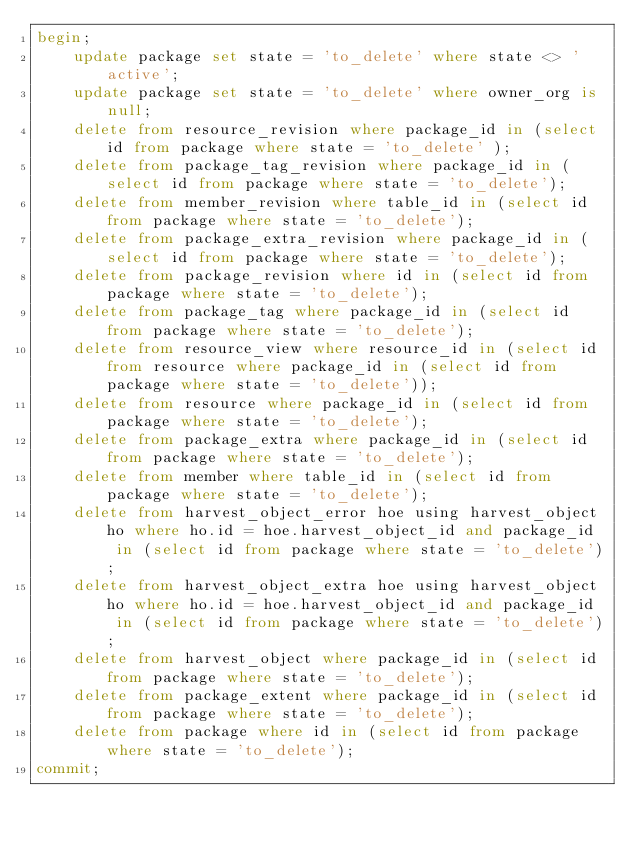Convert code to text. <code><loc_0><loc_0><loc_500><loc_500><_SQL_>begin; 
    update package set state = 'to_delete' where state <> 'active';
    update package set state = 'to_delete' where owner_org is null;
    delete from resource_revision where package_id in (select id from package where state = 'to_delete' );
    delete from package_tag_revision where package_id in (select id from package where state = 'to_delete');
    delete from member_revision where table_id in (select id from package where state = 'to_delete');
    delete from package_extra_revision where package_id in (select id from package where state = 'to_delete');
    delete from package_revision where id in (select id from package where state = 'to_delete');
    delete from package_tag where package_id in (select id from package where state = 'to_delete');
    delete from resource_view where resource_id in (select id from resource where package_id in (select id from package where state = 'to_delete'));
    delete from resource where package_id in (select id from package where state = 'to_delete');
    delete from package_extra where package_id in (select id from package where state = 'to_delete');
    delete from member where table_id in (select id from package where state = 'to_delete');
    delete from harvest_object_error hoe using harvest_object ho where ho.id = hoe.harvest_object_id and package_id  in (select id from package where state = 'to_delete');
    delete from harvest_object_extra hoe using harvest_object ho where ho.id = hoe.harvest_object_id and package_id  in (select id from package where state = 'to_delete');
    delete from harvest_object where package_id in (select id from package where state = 'to_delete');
    delete from package_extent where package_id in (select id from package where state = 'to_delete');
    delete from package where id in (select id from package where state = 'to_delete'); 
commit;
</code> 